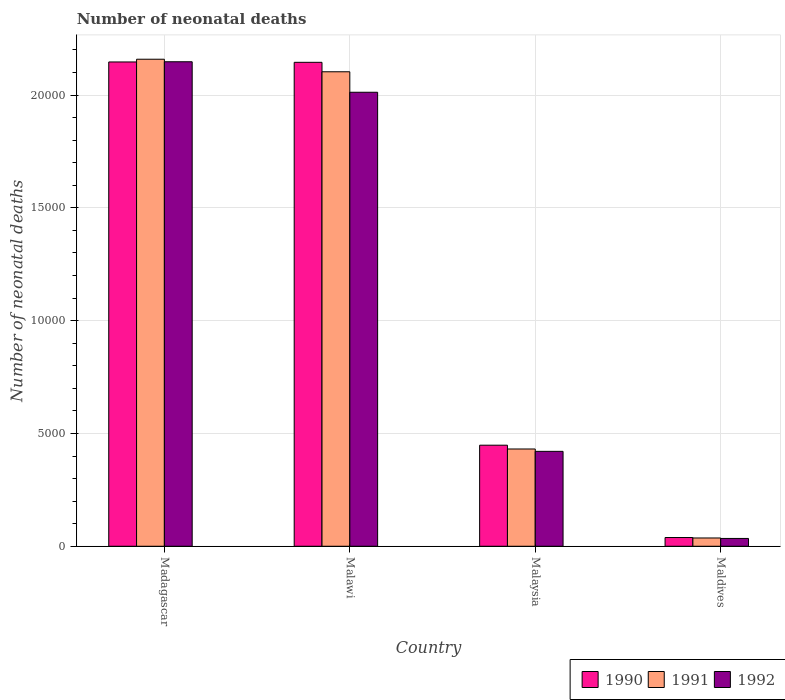How many different coloured bars are there?
Ensure brevity in your answer.  3. How many groups of bars are there?
Your answer should be very brief. 4. Are the number of bars on each tick of the X-axis equal?
Your response must be concise. Yes. How many bars are there on the 4th tick from the left?
Give a very brief answer. 3. How many bars are there on the 2nd tick from the right?
Offer a terse response. 3. What is the label of the 2nd group of bars from the left?
Keep it short and to the point. Malawi. In how many cases, is the number of bars for a given country not equal to the number of legend labels?
Your response must be concise. 0. What is the number of neonatal deaths in in 1990 in Maldives?
Ensure brevity in your answer.  387. Across all countries, what is the maximum number of neonatal deaths in in 1991?
Your response must be concise. 2.16e+04. Across all countries, what is the minimum number of neonatal deaths in in 1991?
Keep it short and to the point. 367. In which country was the number of neonatal deaths in in 1990 maximum?
Provide a short and direct response. Madagascar. In which country was the number of neonatal deaths in in 1992 minimum?
Provide a succinct answer. Maldives. What is the total number of neonatal deaths in in 1990 in the graph?
Give a very brief answer. 4.78e+04. What is the difference between the number of neonatal deaths in in 1990 in Malawi and that in Malaysia?
Keep it short and to the point. 1.70e+04. What is the difference between the number of neonatal deaths in in 1992 in Malaysia and the number of neonatal deaths in in 1991 in Madagascar?
Provide a succinct answer. -1.74e+04. What is the average number of neonatal deaths in in 1992 per country?
Give a very brief answer. 1.15e+04. What is the difference between the number of neonatal deaths in of/in 1991 and number of neonatal deaths in of/in 1990 in Malaysia?
Your answer should be very brief. -168. What is the ratio of the number of neonatal deaths in in 1990 in Malawi to that in Maldives?
Your response must be concise. 55.42. What is the difference between the highest and the second highest number of neonatal deaths in in 1992?
Give a very brief answer. 1.73e+04. What is the difference between the highest and the lowest number of neonatal deaths in in 1992?
Your answer should be very brief. 2.11e+04. In how many countries, is the number of neonatal deaths in in 1990 greater than the average number of neonatal deaths in in 1990 taken over all countries?
Provide a short and direct response. 2. Is the sum of the number of neonatal deaths in in 1992 in Malawi and Malaysia greater than the maximum number of neonatal deaths in in 1990 across all countries?
Your response must be concise. Yes. What does the 3rd bar from the left in Maldives represents?
Give a very brief answer. 1992. What does the 3rd bar from the right in Maldives represents?
Provide a short and direct response. 1990. Is it the case that in every country, the sum of the number of neonatal deaths in in 1991 and number of neonatal deaths in in 1992 is greater than the number of neonatal deaths in in 1990?
Ensure brevity in your answer.  Yes. Are all the bars in the graph horizontal?
Make the answer very short. No. How many countries are there in the graph?
Give a very brief answer. 4. Are the values on the major ticks of Y-axis written in scientific E-notation?
Your response must be concise. No. Where does the legend appear in the graph?
Provide a succinct answer. Bottom right. How are the legend labels stacked?
Your answer should be very brief. Horizontal. What is the title of the graph?
Provide a short and direct response. Number of neonatal deaths. What is the label or title of the Y-axis?
Keep it short and to the point. Number of neonatal deaths. What is the Number of neonatal deaths of 1990 in Madagascar?
Make the answer very short. 2.15e+04. What is the Number of neonatal deaths in 1991 in Madagascar?
Your answer should be compact. 2.16e+04. What is the Number of neonatal deaths in 1992 in Madagascar?
Make the answer very short. 2.15e+04. What is the Number of neonatal deaths in 1990 in Malawi?
Provide a succinct answer. 2.14e+04. What is the Number of neonatal deaths of 1991 in Malawi?
Ensure brevity in your answer.  2.10e+04. What is the Number of neonatal deaths in 1992 in Malawi?
Your answer should be compact. 2.01e+04. What is the Number of neonatal deaths in 1990 in Malaysia?
Make the answer very short. 4479. What is the Number of neonatal deaths of 1991 in Malaysia?
Your answer should be very brief. 4311. What is the Number of neonatal deaths of 1992 in Malaysia?
Make the answer very short. 4206. What is the Number of neonatal deaths in 1990 in Maldives?
Ensure brevity in your answer.  387. What is the Number of neonatal deaths of 1991 in Maldives?
Offer a terse response. 367. What is the Number of neonatal deaths of 1992 in Maldives?
Make the answer very short. 346. Across all countries, what is the maximum Number of neonatal deaths in 1990?
Offer a very short reply. 2.15e+04. Across all countries, what is the maximum Number of neonatal deaths in 1991?
Your answer should be very brief. 2.16e+04. Across all countries, what is the maximum Number of neonatal deaths of 1992?
Your response must be concise. 2.15e+04. Across all countries, what is the minimum Number of neonatal deaths in 1990?
Provide a succinct answer. 387. Across all countries, what is the minimum Number of neonatal deaths in 1991?
Your answer should be very brief. 367. Across all countries, what is the minimum Number of neonatal deaths of 1992?
Make the answer very short. 346. What is the total Number of neonatal deaths of 1990 in the graph?
Give a very brief answer. 4.78e+04. What is the total Number of neonatal deaths of 1991 in the graph?
Provide a succinct answer. 4.73e+04. What is the total Number of neonatal deaths of 1992 in the graph?
Provide a short and direct response. 4.61e+04. What is the difference between the Number of neonatal deaths of 1991 in Madagascar and that in Malawi?
Provide a short and direct response. 556. What is the difference between the Number of neonatal deaths of 1992 in Madagascar and that in Malawi?
Ensure brevity in your answer.  1352. What is the difference between the Number of neonatal deaths in 1990 in Madagascar and that in Malaysia?
Your answer should be compact. 1.70e+04. What is the difference between the Number of neonatal deaths of 1991 in Madagascar and that in Malaysia?
Make the answer very short. 1.73e+04. What is the difference between the Number of neonatal deaths of 1992 in Madagascar and that in Malaysia?
Keep it short and to the point. 1.73e+04. What is the difference between the Number of neonatal deaths in 1990 in Madagascar and that in Maldives?
Your answer should be compact. 2.11e+04. What is the difference between the Number of neonatal deaths of 1991 in Madagascar and that in Maldives?
Your answer should be compact. 2.12e+04. What is the difference between the Number of neonatal deaths of 1992 in Madagascar and that in Maldives?
Offer a terse response. 2.11e+04. What is the difference between the Number of neonatal deaths in 1990 in Malawi and that in Malaysia?
Keep it short and to the point. 1.70e+04. What is the difference between the Number of neonatal deaths in 1991 in Malawi and that in Malaysia?
Offer a very short reply. 1.67e+04. What is the difference between the Number of neonatal deaths in 1992 in Malawi and that in Malaysia?
Offer a very short reply. 1.59e+04. What is the difference between the Number of neonatal deaths of 1990 in Malawi and that in Maldives?
Offer a terse response. 2.11e+04. What is the difference between the Number of neonatal deaths in 1991 in Malawi and that in Maldives?
Offer a terse response. 2.07e+04. What is the difference between the Number of neonatal deaths of 1992 in Malawi and that in Maldives?
Give a very brief answer. 1.98e+04. What is the difference between the Number of neonatal deaths in 1990 in Malaysia and that in Maldives?
Provide a short and direct response. 4092. What is the difference between the Number of neonatal deaths in 1991 in Malaysia and that in Maldives?
Offer a terse response. 3944. What is the difference between the Number of neonatal deaths in 1992 in Malaysia and that in Maldives?
Your answer should be compact. 3860. What is the difference between the Number of neonatal deaths in 1990 in Madagascar and the Number of neonatal deaths in 1991 in Malawi?
Ensure brevity in your answer.  435. What is the difference between the Number of neonatal deaths in 1990 in Madagascar and the Number of neonatal deaths in 1992 in Malawi?
Your response must be concise. 1343. What is the difference between the Number of neonatal deaths of 1991 in Madagascar and the Number of neonatal deaths of 1992 in Malawi?
Your answer should be compact. 1464. What is the difference between the Number of neonatal deaths in 1990 in Madagascar and the Number of neonatal deaths in 1991 in Malaysia?
Make the answer very short. 1.72e+04. What is the difference between the Number of neonatal deaths of 1990 in Madagascar and the Number of neonatal deaths of 1992 in Malaysia?
Provide a short and direct response. 1.73e+04. What is the difference between the Number of neonatal deaths in 1991 in Madagascar and the Number of neonatal deaths in 1992 in Malaysia?
Offer a terse response. 1.74e+04. What is the difference between the Number of neonatal deaths in 1990 in Madagascar and the Number of neonatal deaths in 1991 in Maldives?
Offer a terse response. 2.11e+04. What is the difference between the Number of neonatal deaths of 1990 in Madagascar and the Number of neonatal deaths of 1992 in Maldives?
Provide a short and direct response. 2.11e+04. What is the difference between the Number of neonatal deaths in 1991 in Madagascar and the Number of neonatal deaths in 1992 in Maldives?
Offer a terse response. 2.12e+04. What is the difference between the Number of neonatal deaths in 1990 in Malawi and the Number of neonatal deaths in 1991 in Malaysia?
Provide a short and direct response. 1.71e+04. What is the difference between the Number of neonatal deaths of 1990 in Malawi and the Number of neonatal deaths of 1992 in Malaysia?
Provide a succinct answer. 1.72e+04. What is the difference between the Number of neonatal deaths in 1991 in Malawi and the Number of neonatal deaths in 1992 in Malaysia?
Your answer should be very brief. 1.68e+04. What is the difference between the Number of neonatal deaths of 1990 in Malawi and the Number of neonatal deaths of 1991 in Maldives?
Make the answer very short. 2.11e+04. What is the difference between the Number of neonatal deaths of 1990 in Malawi and the Number of neonatal deaths of 1992 in Maldives?
Give a very brief answer. 2.11e+04. What is the difference between the Number of neonatal deaths of 1991 in Malawi and the Number of neonatal deaths of 1992 in Maldives?
Ensure brevity in your answer.  2.07e+04. What is the difference between the Number of neonatal deaths in 1990 in Malaysia and the Number of neonatal deaths in 1991 in Maldives?
Give a very brief answer. 4112. What is the difference between the Number of neonatal deaths in 1990 in Malaysia and the Number of neonatal deaths in 1992 in Maldives?
Keep it short and to the point. 4133. What is the difference between the Number of neonatal deaths in 1991 in Malaysia and the Number of neonatal deaths in 1992 in Maldives?
Ensure brevity in your answer.  3965. What is the average Number of neonatal deaths of 1990 per country?
Offer a terse response. 1.19e+04. What is the average Number of neonatal deaths of 1991 per country?
Provide a succinct answer. 1.18e+04. What is the average Number of neonatal deaths of 1992 per country?
Keep it short and to the point. 1.15e+04. What is the difference between the Number of neonatal deaths of 1990 and Number of neonatal deaths of 1991 in Madagascar?
Ensure brevity in your answer.  -121. What is the difference between the Number of neonatal deaths of 1991 and Number of neonatal deaths of 1992 in Madagascar?
Provide a succinct answer. 112. What is the difference between the Number of neonatal deaths in 1990 and Number of neonatal deaths in 1991 in Malawi?
Keep it short and to the point. 419. What is the difference between the Number of neonatal deaths of 1990 and Number of neonatal deaths of 1992 in Malawi?
Make the answer very short. 1327. What is the difference between the Number of neonatal deaths in 1991 and Number of neonatal deaths in 1992 in Malawi?
Offer a terse response. 908. What is the difference between the Number of neonatal deaths in 1990 and Number of neonatal deaths in 1991 in Malaysia?
Offer a very short reply. 168. What is the difference between the Number of neonatal deaths in 1990 and Number of neonatal deaths in 1992 in Malaysia?
Your response must be concise. 273. What is the difference between the Number of neonatal deaths of 1991 and Number of neonatal deaths of 1992 in Malaysia?
Offer a very short reply. 105. What is the difference between the Number of neonatal deaths in 1990 and Number of neonatal deaths in 1992 in Maldives?
Your answer should be compact. 41. What is the difference between the Number of neonatal deaths of 1991 and Number of neonatal deaths of 1992 in Maldives?
Your answer should be compact. 21. What is the ratio of the Number of neonatal deaths in 1990 in Madagascar to that in Malawi?
Give a very brief answer. 1. What is the ratio of the Number of neonatal deaths of 1991 in Madagascar to that in Malawi?
Make the answer very short. 1.03. What is the ratio of the Number of neonatal deaths of 1992 in Madagascar to that in Malawi?
Provide a succinct answer. 1.07. What is the ratio of the Number of neonatal deaths of 1990 in Madagascar to that in Malaysia?
Keep it short and to the point. 4.79. What is the ratio of the Number of neonatal deaths of 1991 in Madagascar to that in Malaysia?
Keep it short and to the point. 5.01. What is the ratio of the Number of neonatal deaths in 1992 in Madagascar to that in Malaysia?
Your response must be concise. 5.11. What is the ratio of the Number of neonatal deaths of 1990 in Madagascar to that in Maldives?
Offer a very short reply. 55.47. What is the ratio of the Number of neonatal deaths of 1991 in Madagascar to that in Maldives?
Give a very brief answer. 58.82. What is the ratio of the Number of neonatal deaths of 1992 in Madagascar to that in Maldives?
Keep it short and to the point. 62.06. What is the ratio of the Number of neonatal deaths in 1990 in Malawi to that in Malaysia?
Keep it short and to the point. 4.79. What is the ratio of the Number of neonatal deaths in 1991 in Malawi to that in Malaysia?
Your answer should be very brief. 4.88. What is the ratio of the Number of neonatal deaths of 1992 in Malawi to that in Malaysia?
Keep it short and to the point. 4.78. What is the ratio of the Number of neonatal deaths in 1990 in Malawi to that in Maldives?
Your response must be concise. 55.42. What is the ratio of the Number of neonatal deaths of 1991 in Malawi to that in Maldives?
Your response must be concise. 57.3. What is the ratio of the Number of neonatal deaths in 1992 in Malawi to that in Maldives?
Offer a terse response. 58.16. What is the ratio of the Number of neonatal deaths of 1990 in Malaysia to that in Maldives?
Provide a succinct answer. 11.57. What is the ratio of the Number of neonatal deaths in 1991 in Malaysia to that in Maldives?
Offer a very short reply. 11.75. What is the ratio of the Number of neonatal deaths of 1992 in Malaysia to that in Maldives?
Make the answer very short. 12.16. What is the difference between the highest and the second highest Number of neonatal deaths of 1991?
Your answer should be compact. 556. What is the difference between the highest and the second highest Number of neonatal deaths of 1992?
Provide a succinct answer. 1352. What is the difference between the highest and the lowest Number of neonatal deaths of 1990?
Your answer should be compact. 2.11e+04. What is the difference between the highest and the lowest Number of neonatal deaths in 1991?
Keep it short and to the point. 2.12e+04. What is the difference between the highest and the lowest Number of neonatal deaths of 1992?
Ensure brevity in your answer.  2.11e+04. 